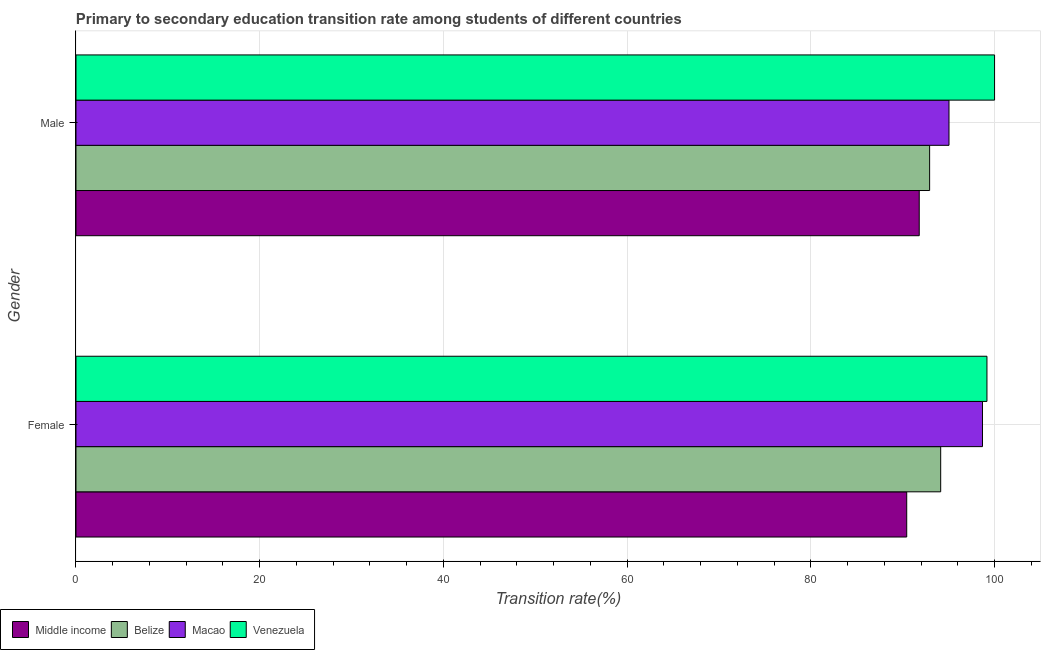How many groups of bars are there?
Make the answer very short. 2. Are the number of bars per tick equal to the number of legend labels?
Ensure brevity in your answer.  Yes. Are the number of bars on each tick of the Y-axis equal?
Provide a short and direct response. Yes. How many bars are there on the 1st tick from the top?
Offer a very short reply. 4. How many bars are there on the 2nd tick from the bottom?
Your answer should be very brief. 4. What is the label of the 2nd group of bars from the top?
Your answer should be very brief. Female. What is the transition rate among male students in Belize?
Provide a succinct answer. 92.93. Across all countries, what is the maximum transition rate among female students?
Provide a succinct answer. 99.17. Across all countries, what is the minimum transition rate among female students?
Your answer should be very brief. 90.44. In which country was the transition rate among male students maximum?
Your response must be concise. Venezuela. What is the total transition rate among male students in the graph?
Offer a terse response. 379.77. What is the difference between the transition rate among female students in Middle income and that in Belize?
Keep it short and to the point. -3.7. What is the difference between the transition rate among male students in Middle income and the transition rate among female students in Venezuela?
Offer a very short reply. -7.37. What is the average transition rate among female students per country?
Your answer should be very brief. 95.61. What is the difference between the transition rate among female students and transition rate among male students in Macao?
Keep it short and to the point. 3.65. In how many countries, is the transition rate among female students greater than 20 %?
Give a very brief answer. 4. What is the ratio of the transition rate among male students in Macao to that in Belize?
Offer a very short reply. 1.02. Is the transition rate among male students in Belize less than that in Middle income?
Make the answer very short. No. What does the 1st bar from the top in Female represents?
Ensure brevity in your answer.  Venezuela. What does the 1st bar from the bottom in Male represents?
Provide a short and direct response. Middle income. Are all the bars in the graph horizontal?
Ensure brevity in your answer.  Yes. How many countries are there in the graph?
Ensure brevity in your answer.  4. What is the difference between two consecutive major ticks on the X-axis?
Provide a succinct answer. 20. Does the graph contain any zero values?
Your response must be concise. No. How are the legend labels stacked?
Your answer should be very brief. Horizontal. What is the title of the graph?
Your response must be concise. Primary to secondary education transition rate among students of different countries. Does "Virgin Islands" appear as one of the legend labels in the graph?
Your response must be concise. No. What is the label or title of the X-axis?
Your response must be concise. Transition rate(%). What is the label or title of the Y-axis?
Give a very brief answer. Gender. What is the Transition rate(%) in Middle income in Female?
Provide a short and direct response. 90.44. What is the Transition rate(%) of Belize in Female?
Your answer should be compact. 94.13. What is the Transition rate(%) of Macao in Female?
Keep it short and to the point. 98.68. What is the Transition rate(%) of Venezuela in Female?
Give a very brief answer. 99.17. What is the Transition rate(%) in Middle income in Male?
Ensure brevity in your answer.  91.8. What is the Transition rate(%) of Belize in Male?
Make the answer very short. 92.93. What is the Transition rate(%) in Macao in Male?
Offer a very short reply. 95.04. What is the Transition rate(%) in Venezuela in Male?
Your response must be concise. 100. Across all Gender, what is the maximum Transition rate(%) in Middle income?
Keep it short and to the point. 91.8. Across all Gender, what is the maximum Transition rate(%) of Belize?
Your answer should be very brief. 94.13. Across all Gender, what is the maximum Transition rate(%) of Macao?
Your response must be concise. 98.68. Across all Gender, what is the maximum Transition rate(%) in Venezuela?
Make the answer very short. 100. Across all Gender, what is the minimum Transition rate(%) of Middle income?
Your answer should be compact. 90.44. Across all Gender, what is the minimum Transition rate(%) in Belize?
Your answer should be very brief. 92.93. Across all Gender, what is the minimum Transition rate(%) in Macao?
Your answer should be compact. 95.04. Across all Gender, what is the minimum Transition rate(%) in Venezuela?
Make the answer very short. 99.17. What is the total Transition rate(%) of Middle income in the graph?
Provide a succinct answer. 182.24. What is the total Transition rate(%) of Belize in the graph?
Ensure brevity in your answer.  187.07. What is the total Transition rate(%) in Macao in the graph?
Provide a succinct answer. 193.72. What is the total Transition rate(%) of Venezuela in the graph?
Your response must be concise. 199.17. What is the difference between the Transition rate(%) of Middle income in Female and that in Male?
Your answer should be compact. -1.36. What is the difference between the Transition rate(%) in Belize in Female and that in Male?
Your response must be concise. 1.2. What is the difference between the Transition rate(%) of Macao in Female and that in Male?
Keep it short and to the point. 3.65. What is the difference between the Transition rate(%) of Venezuela in Female and that in Male?
Provide a short and direct response. -0.83. What is the difference between the Transition rate(%) of Middle income in Female and the Transition rate(%) of Belize in Male?
Your answer should be compact. -2.49. What is the difference between the Transition rate(%) of Middle income in Female and the Transition rate(%) of Macao in Male?
Provide a succinct answer. -4.6. What is the difference between the Transition rate(%) of Middle income in Female and the Transition rate(%) of Venezuela in Male?
Make the answer very short. -9.56. What is the difference between the Transition rate(%) of Belize in Female and the Transition rate(%) of Macao in Male?
Provide a succinct answer. -0.9. What is the difference between the Transition rate(%) of Belize in Female and the Transition rate(%) of Venezuela in Male?
Give a very brief answer. -5.87. What is the difference between the Transition rate(%) in Macao in Female and the Transition rate(%) in Venezuela in Male?
Provide a short and direct response. -1.32. What is the average Transition rate(%) in Middle income per Gender?
Your response must be concise. 91.12. What is the average Transition rate(%) of Belize per Gender?
Ensure brevity in your answer.  93.53. What is the average Transition rate(%) of Macao per Gender?
Give a very brief answer. 96.86. What is the average Transition rate(%) of Venezuela per Gender?
Your response must be concise. 99.59. What is the difference between the Transition rate(%) of Middle income and Transition rate(%) of Belize in Female?
Make the answer very short. -3.7. What is the difference between the Transition rate(%) in Middle income and Transition rate(%) in Macao in Female?
Your answer should be very brief. -8.25. What is the difference between the Transition rate(%) of Middle income and Transition rate(%) of Venezuela in Female?
Give a very brief answer. -8.73. What is the difference between the Transition rate(%) in Belize and Transition rate(%) in Macao in Female?
Make the answer very short. -4.55. What is the difference between the Transition rate(%) of Belize and Transition rate(%) of Venezuela in Female?
Provide a short and direct response. -5.04. What is the difference between the Transition rate(%) in Macao and Transition rate(%) in Venezuela in Female?
Your answer should be compact. -0.49. What is the difference between the Transition rate(%) in Middle income and Transition rate(%) in Belize in Male?
Keep it short and to the point. -1.13. What is the difference between the Transition rate(%) of Middle income and Transition rate(%) of Macao in Male?
Ensure brevity in your answer.  -3.24. What is the difference between the Transition rate(%) in Middle income and Transition rate(%) in Venezuela in Male?
Ensure brevity in your answer.  -8.2. What is the difference between the Transition rate(%) in Belize and Transition rate(%) in Macao in Male?
Provide a short and direct response. -2.11. What is the difference between the Transition rate(%) of Belize and Transition rate(%) of Venezuela in Male?
Give a very brief answer. -7.07. What is the difference between the Transition rate(%) of Macao and Transition rate(%) of Venezuela in Male?
Ensure brevity in your answer.  -4.96. What is the ratio of the Transition rate(%) in Middle income in Female to that in Male?
Ensure brevity in your answer.  0.99. What is the ratio of the Transition rate(%) in Belize in Female to that in Male?
Your response must be concise. 1.01. What is the ratio of the Transition rate(%) of Macao in Female to that in Male?
Keep it short and to the point. 1.04. What is the difference between the highest and the second highest Transition rate(%) of Middle income?
Offer a terse response. 1.36. What is the difference between the highest and the second highest Transition rate(%) of Belize?
Offer a very short reply. 1.2. What is the difference between the highest and the second highest Transition rate(%) in Macao?
Provide a short and direct response. 3.65. What is the difference between the highest and the second highest Transition rate(%) in Venezuela?
Your answer should be compact. 0.83. What is the difference between the highest and the lowest Transition rate(%) in Middle income?
Provide a short and direct response. 1.36. What is the difference between the highest and the lowest Transition rate(%) in Belize?
Provide a short and direct response. 1.2. What is the difference between the highest and the lowest Transition rate(%) in Macao?
Your answer should be very brief. 3.65. What is the difference between the highest and the lowest Transition rate(%) in Venezuela?
Keep it short and to the point. 0.83. 